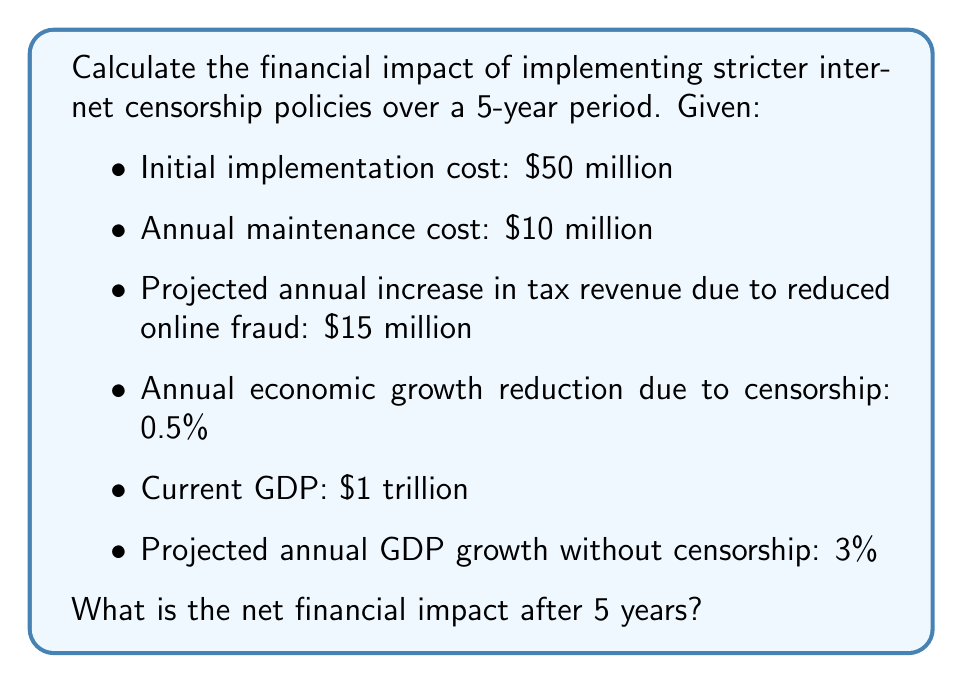Teach me how to tackle this problem. 1. Calculate the total cost of implementation and maintenance over 5 years:
   Initial cost + (Annual maintenance × 5 years)
   $$ 50,000,000 + (10,000,000 × 5) = $100,000,000 $$

2. Calculate the total increase in tax revenue over 5 years:
   Annual increase × 5 years
   $$ 15,000,000 × 5 = $75,000,000 $$

3. Calculate the GDP growth without censorship over 5 years:
   $$ GDP_{5} = 1,000,000,000,000 × (1 + 0.03)^5 = $1,159,274,300,000 $$

4. Calculate the GDP growth with censorship over 5 years:
   Annual growth rate with censorship = 3% - 0.5% = 2.5%
   $$ GDP_{5c} = 1,000,000,000,000 × (1 + 0.025)^5 = $1,131,408,400,000 $$

5. Calculate the difference in GDP after 5 years:
   $$ 1,159,274,300,000 - 1,131,408,400,000 = $27,865,900,000 $$

6. Calculate the net financial impact:
   (Increase in tax revenue - Implementation and maintenance costs) - GDP difference
   $$ (75,000,000 - 100,000,000) - 27,865,900,000 = -$27,890,900,000 $$
Answer: -$27,890,900,000 